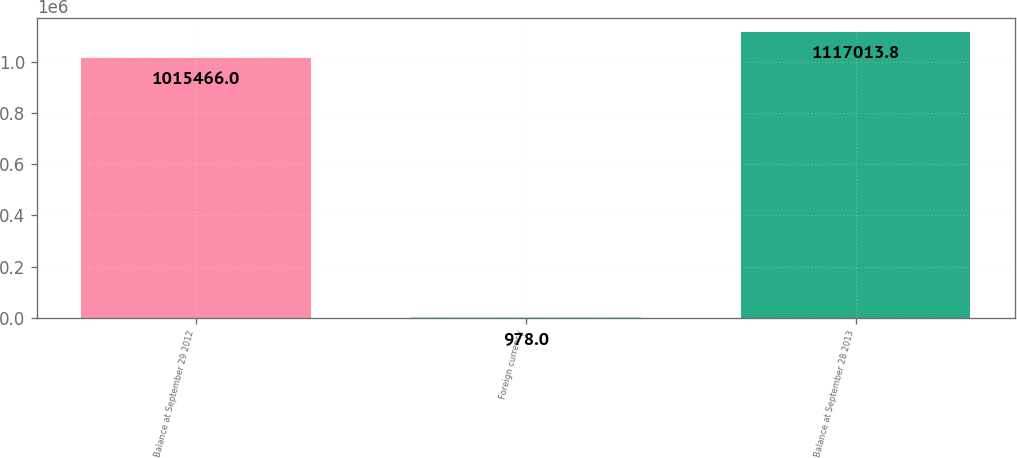Convert chart. <chart><loc_0><loc_0><loc_500><loc_500><bar_chart><fcel>Balance at September 29 2012<fcel>Foreign currency<fcel>Balance at September 28 2013<nl><fcel>1.01547e+06<fcel>978<fcel>1.11701e+06<nl></chart> 